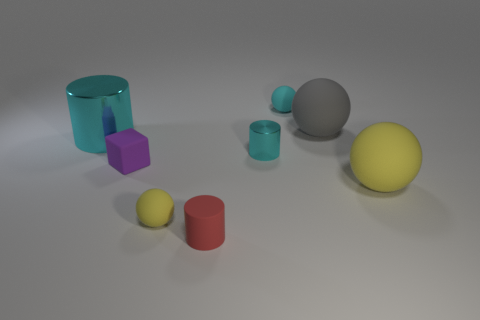How many cyan cylinders must be subtracted to get 1 cyan cylinders? 1 Subtract all matte cylinders. How many cylinders are left? 2 Add 2 gray matte balls. How many objects exist? 10 Subtract all red cylinders. How many cylinders are left? 2 Subtract 1 yellow balls. How many objects are left? 7 Subtract all cylinders. How many objects are left? 5 Subtract all purple cylinders. Subtract all green blocks. How many cylinders are left? 3 Subtract all red cylinders. How many yellow spheres are left? 2 Subtract all tiny cyan spheres. Subtract all tiny yellow balls. How many objects are left? 6 Add 4 matte blocks. How many matte blocks are left? 5 